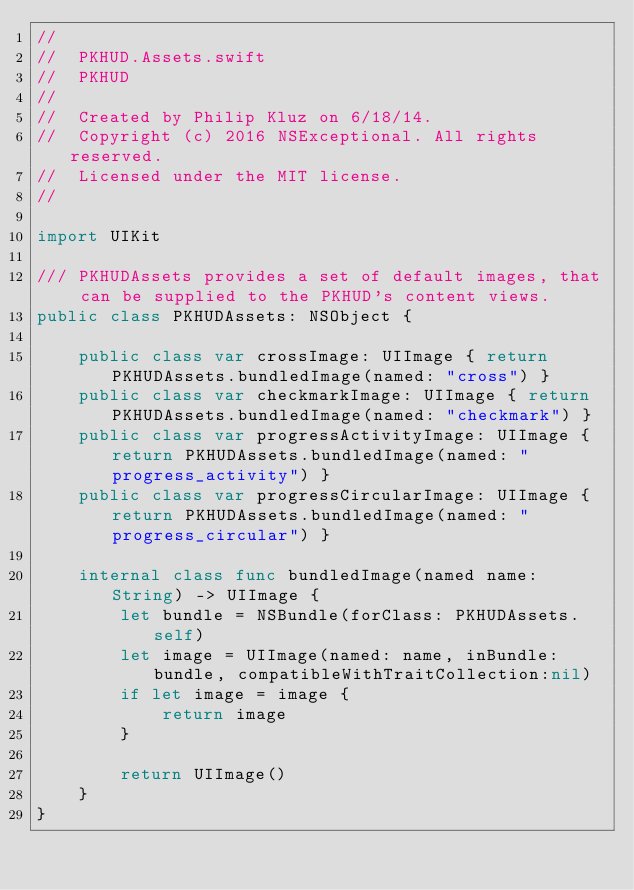Convert code to text. <code><loc_0><loc_0><loc_500><loc_500><_Swift_>//
//  PKHUD.Assets.swift
//  PKHUD
//
//  Created by Philip Kluz on 6/18/14.
//  Copyright (c) 2016 NSExceptional. All rights reserved.
//  Licensed under the MIT license.
//

import UIKit

/// PKHUDAssets provides a set of default images, that can be supplied to the PKHUD's content views.
public class PKHUDAssets: NSObject {
    
    public class var crossImage: UIImage { return PKHUDAssets.bundledImage(named: "cross") }
    public class var checkmarkImage: UIImage { return PKHUDAssets.bundledImage(named: "checkmark") }
    public class var progressActivityImage: UIImage { return PKHUDAssets.bundledImage(named: "progress_activity") }
    public class var progressCircularImage: UIImage { return PKHUDAssets.bundledImage(named: "progress_circular") }
    
    internal class func bundledImage(named name: String) -> UIImage {
        let bundle = NSBundle(forClass: PKHUDAssets.self)
        let image = UIImage(named: name, inBundle:bundle, compatibleWithTraitCollection:nil)
        if let image = image {
            return image
        }
        
        return UIImage()
    }
}
</code> 